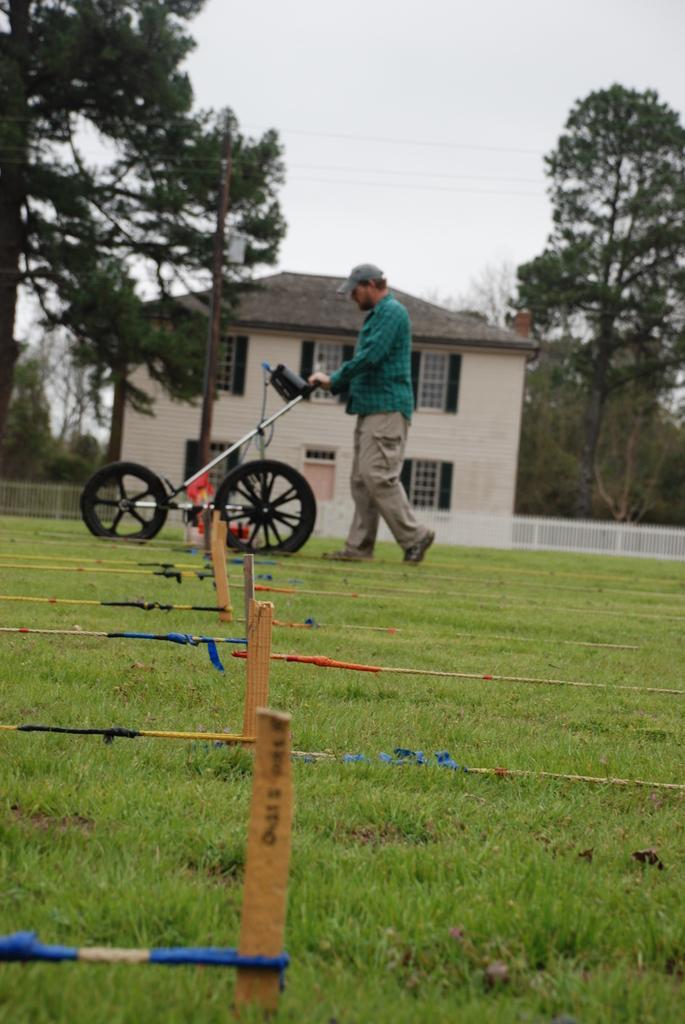Please provide a concise description of this image. Here we can see a cart and a man on the ground. This is grass. In the background we can see a house, pole, fence, trees, and sky. 